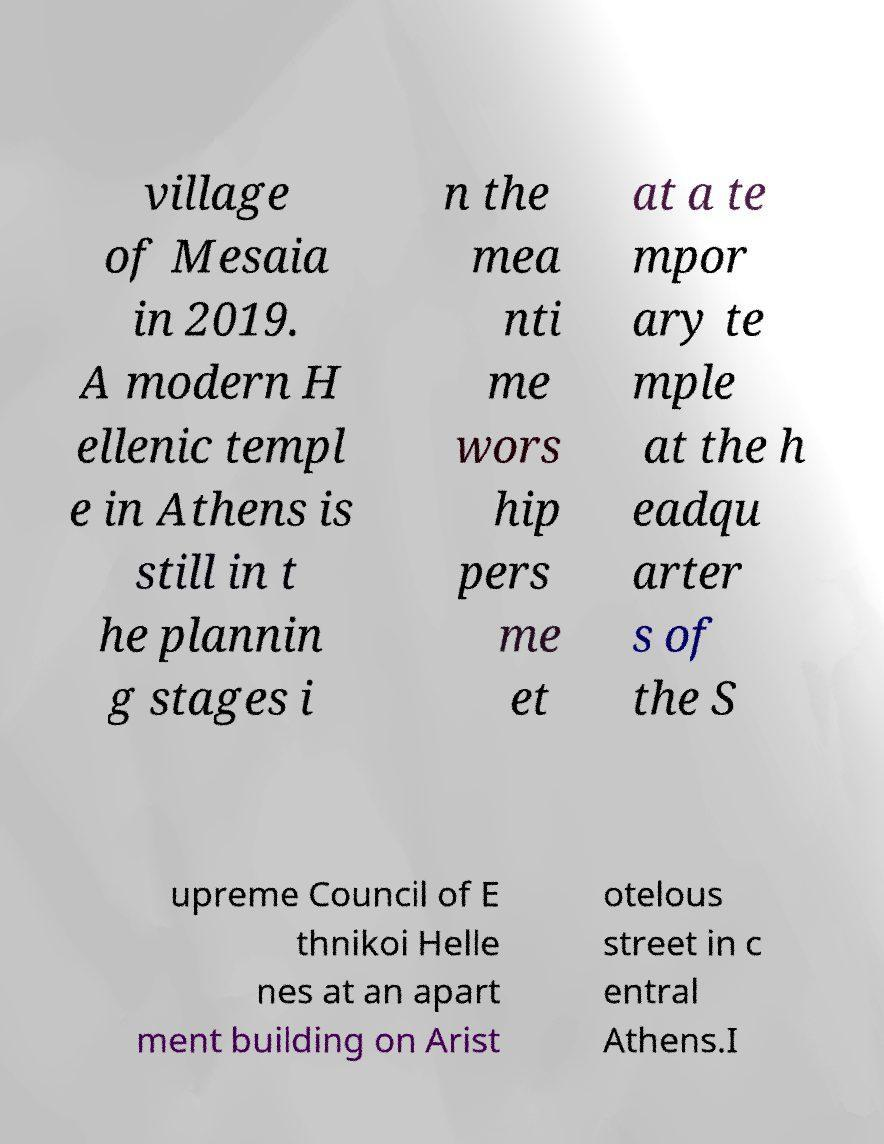Please read and relay the text visible in this image. What does it say? village of Mesaia in 2019. A modern H ellenic templ e in Athens is still in t he plannin g stages i n the mea nti me wors hip pers me et at a te mpor ary te mple at the h eadqu arter s of the S upreme Council of E thnikoi Helle nes at an apart ment building on Arist otelous street in c entral Athens.I 